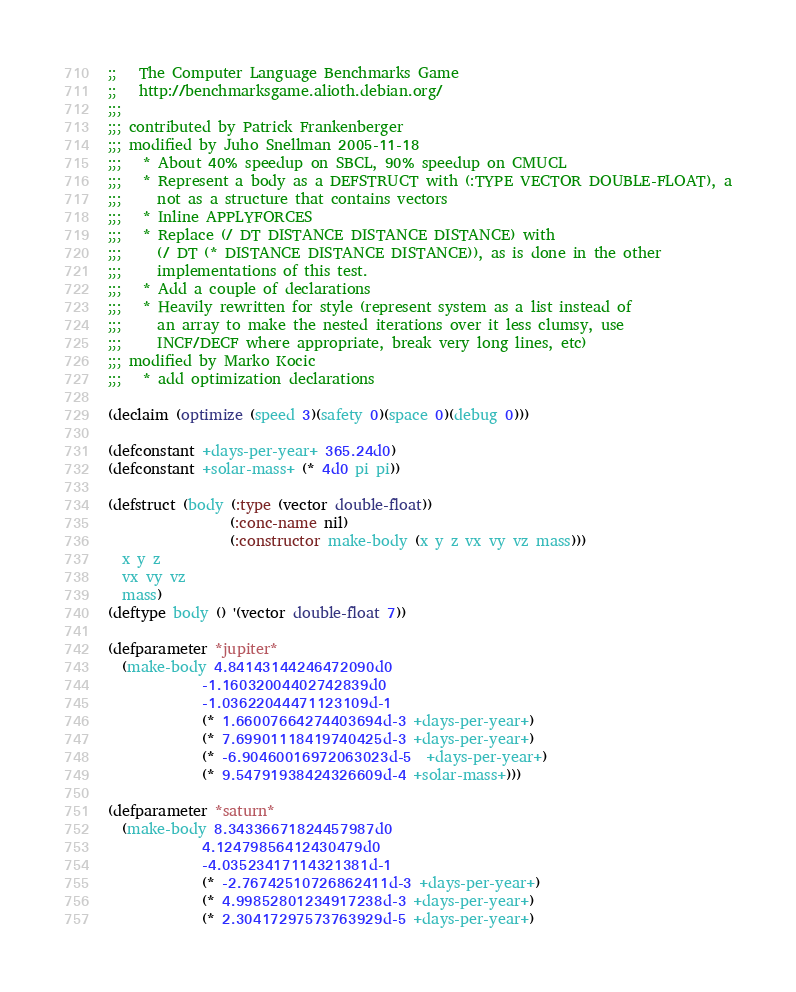Convert code to text. <code><loc_0><loc_0><loc_500><loc_500><_Lisp_>;;   The Computer Language Benchmarks Game
;;   http://benchmarksgame.alioth.debian.org/
;;;
;;; contributed by Patrick Frankenberger
;;; modified by Juho Snellman 2005-11-18
;;;   * About 40% speedup on SBCL, 90% speedup on CMUCL
;;;   * Represent a body as a DEFSTRUCT with (:TYPE VECTOR DOUBLE-FLOAT), a
;;;     not as a structure that contains vectors
;;;   * Inline APPLYFORCES
;;;   * Replace (/ DT DISTANCE DISTANCE DISTANCE) with
;;;     (/ DT (* DISTANCE DISTANCE DISTANCE)), as is done in the other
;;;     implementations of this test.
;;;   * Add a couple of declarations
;;;   * Heavily rewritten for style (represent system as a list instead of
;;;     an array to make the nested iterations over it less clumsy, use
;;;     INCF/DECF where appropriate, break very long lines, etc)
;;; modified by Marko Kocic 
;;;   * add optimization declarations

(declaim (optimize (speed 3)(safety 0)(space 0)(debug 0)))

(defconstant +days-per-year+ 365.24d0)
(defconstant +solar-mass+ (* 4d0 pi pi))

(defstruct (body (:type (vector double-float))
                 (:conc-name nil)
                 (:constructor make-body (x y z vx vy vz mass)))
  x y z
  vx vy vz
  mass)
(deftype body () '(vector double-float 7))

(defparameter *jupiter*
  (make-body 4.84143144246472090d0
             -1.16032004402742839d0
             -1.03622044471123109d-1
             (* 1.66007664274403694d-3 +days-per-year+)
             (* 7.69901118419740425d-3 +days-per-year+)
             (* -6.90460016972063023d-5  +days-per-year+)
             (* 9.54791938424326609d-4 +solar-mass+)))

(defparameter *saturn*
  (make-body 8.34336671824457987d0
             4.12479856412430479d0
             -4.03523417114321381d-1
             (* -2.76742510726862411d-3 +days-per-year+)
             (* 4.99852801234917238d-3 +days-per-year+)
             (* 2.30417297573763929d-5 +days-per-year+)</code> 